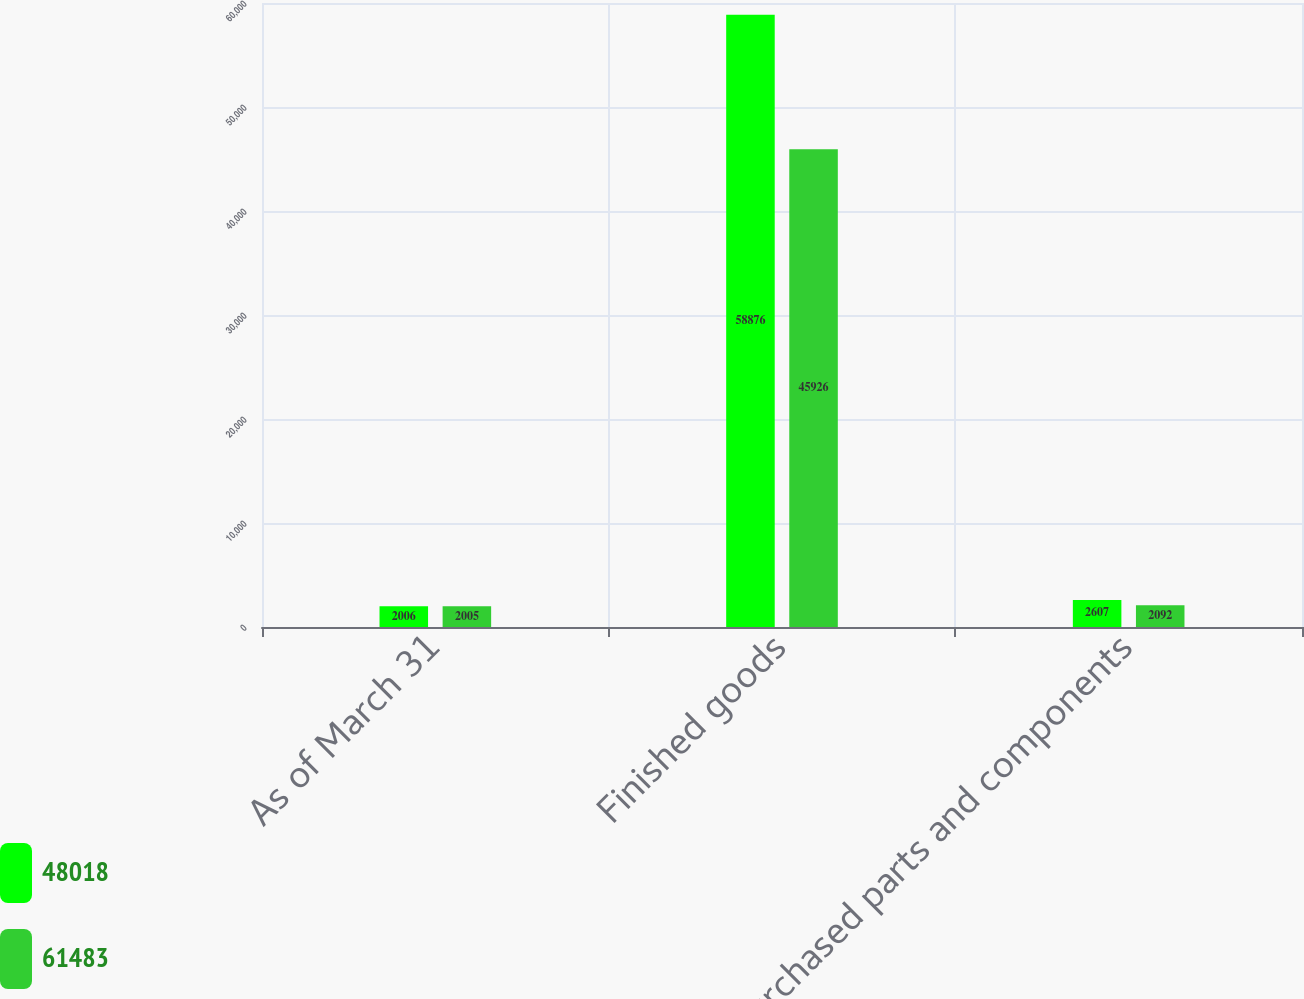Convert chart. <chart><loc_0><loc_0><loc_500><loc_500><stacked_bar_chart><ecel><fcel>As of March 31<fcel>Finished goods<fcel>Purchased parts and components<nl><fcel>48018<fcel>2006<fcel>58876<fcel>2607<nl><fcel>61483<fcel>2005<fcel>45926<fcel>2092<nl></chart> 